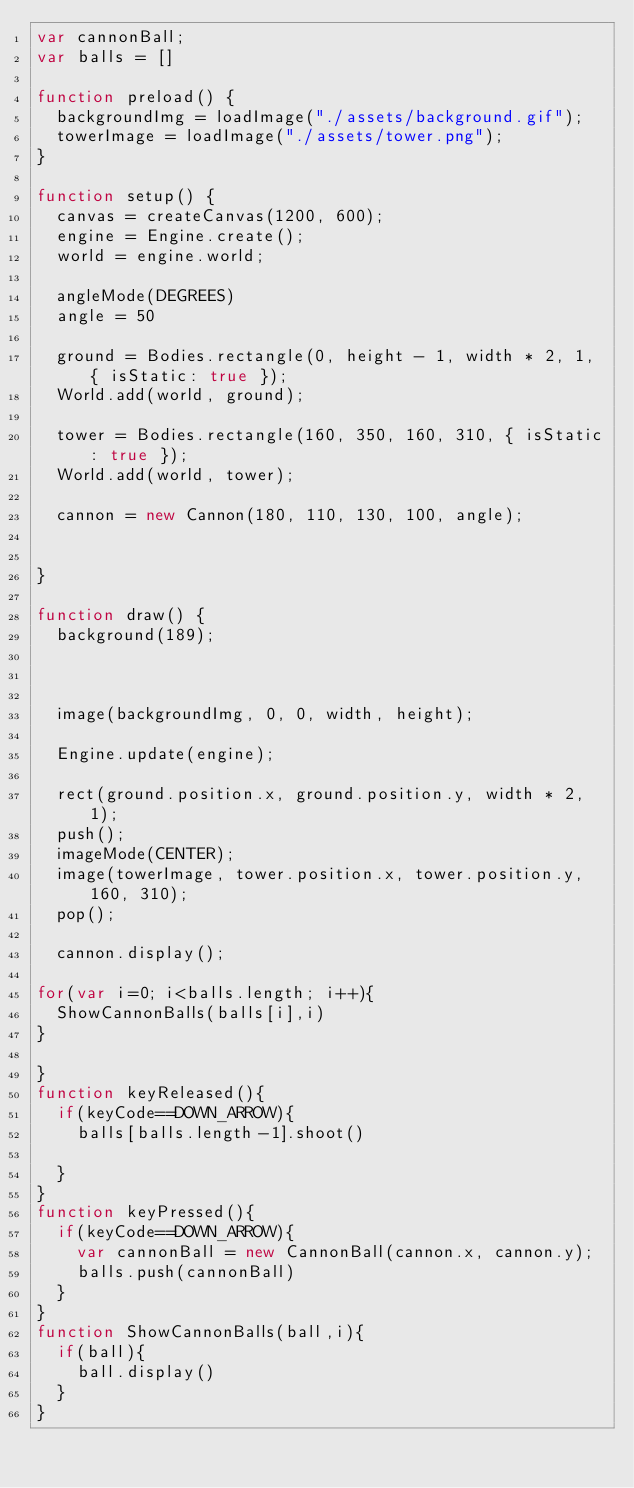Convert code to text. <code><loc_0><loc_0><loc_500><loc_500><_JavaScript_>var cannonBall;
var balls = []

function preload() {
  backgroundImg = loadImage("./assets/background.gif");
  towerImage = loadImage("./assets/tower.png");
}

function setup() {
  canvas = createCanvas(1200, 600);
  engine = Engine.create();
  world = engine.world;
  
  angleMode(DEGREES)
  angle = 50

  ground = Bodies.rectangle(0, height - 1, width * 2, 1, { isStatic: true });
  World.add(world, ground);

  tower = Bodies.rectangle(160, 350, 160, 310, { isStatic: true });
  World.add(world, tower);

  cannon = new Cannon(180, 110, 130, 100, angle);

  
}

function draw() {
  background(189);

  

  image(backgroundImg, 0, 0, width, height);

  Engine.update(engine);

  rect(ground.position.x, ground.position.y, width * 2, 1);
  push();
  imageMode(CENTER);
  image(towerImage, tower.position.x, tower.position.y, 160, 310);
  pop();

  cannon.display();

for(var i=0; i<balls.length; i++){
  ShowCannonBalls(balls[i],i)
}
  
}
function keyReleased(){
  if(keyCode==DOWN_ARROW){
    balls[balls.length-1].shoot()
    
  }
}
function keyPressed(){
  if(keyCode==DOWN_ARROW){
    var cannonBall = new CannonBall(cannon.x, cannon.y);
    balls.push(cannonBall)
  }
}
function ShowCannonBalls(ball,i){
  if(ball){
    ball.display()
  }
}


</code> 